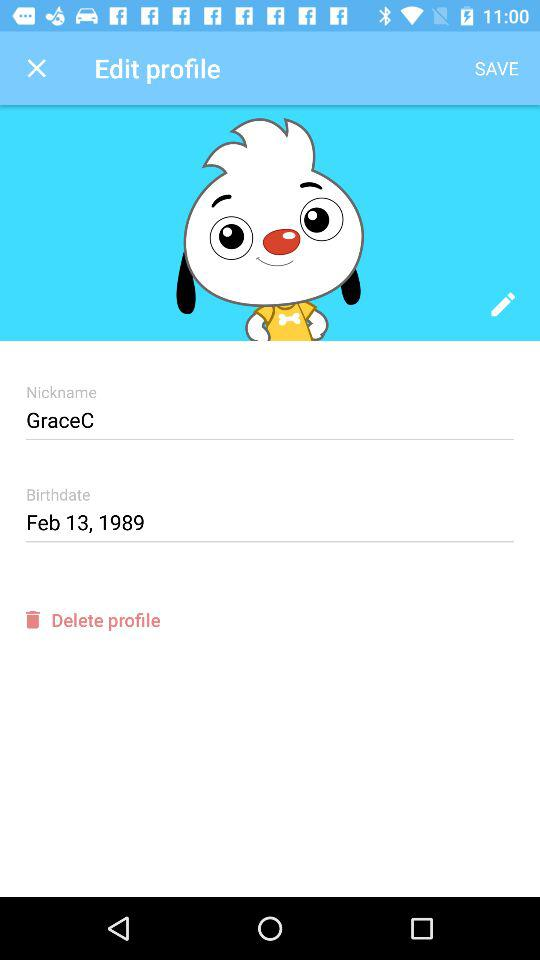What is the birthday date? The birthday date is February 13, 1989. 